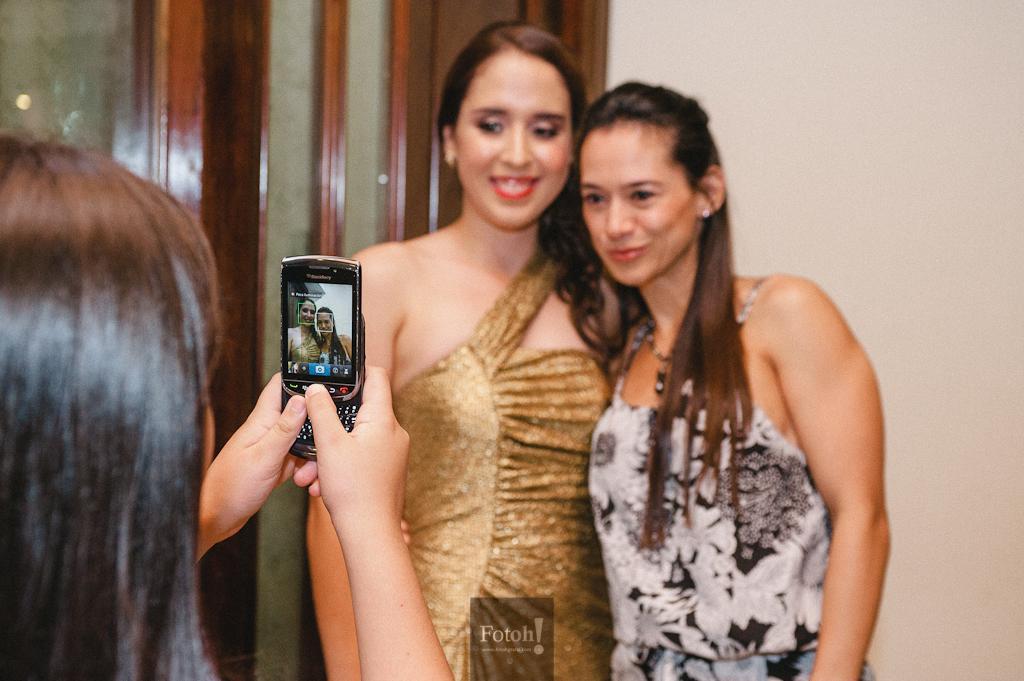Please provide a concise description of this image. In this image we can see three women standing. In that a woman is holding a mobile phone. On the backside we can see a door and a wall. 